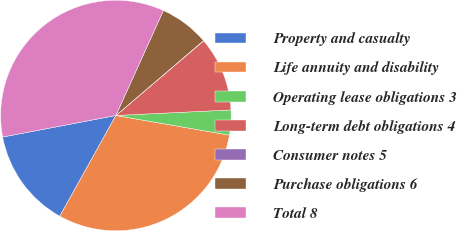Convert chart. <chart><loc_0><loc_0><loc_500><loc_500><pie_chart><fcel>Property and casualty<fcel>Life annuity and disability<fcel>Operating lease obligations 3<fcel>Long-term debt obligations 4<fcel>Consumer notes 5<fcel>Purchase obligations 6<fcel>Total 8<nl><fcel>13.92%<fcel>30.36%<fcel>3.5%<fcel>10.45%<fcel>0.03%<fcel>6.98%<fcel>34.76%<nl></chart> 